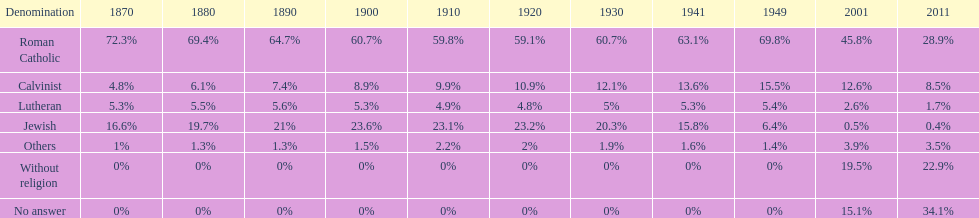What is the number of denominations that maintained a minimum of 20%? 1. 